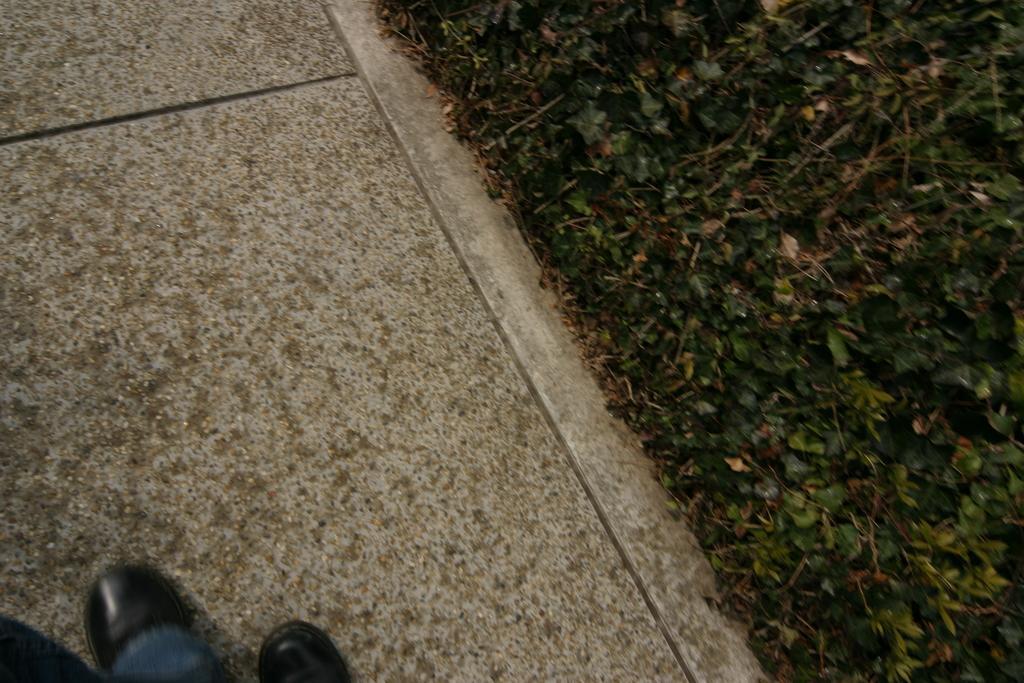Could you give a brief overview of what you see in this image? On the left it is footpath, on the footpath there are persons legs. On the right there are plants. 